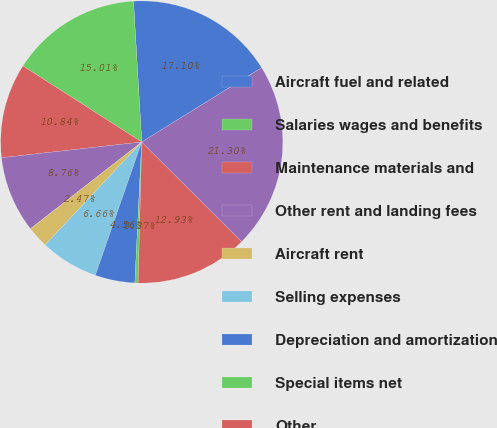<chart> <loc_0><loc_0><loc_500><loc_500><pie_chart><fcel>Aircraft fuel and related<fcel>Salaries wages and benefits<fcel>Maintenance materials and<fcel>Other rent and landing fees<fcel>Aircraft rent<fcel>Selling expenses<fcel>Depreciation and amortization<fcel>Special items net<fcel>Other<fcel>Total mainline CASM<nl><fcel>17.1%<fcel>15.01%<fcel>10.84%<fcel>8.76%<fcel>2.47%<fcel>6.66%<fcel>4.56%<fcel>0.37%<fcel>12.93%<fcel>21.3%<nl></chart> 